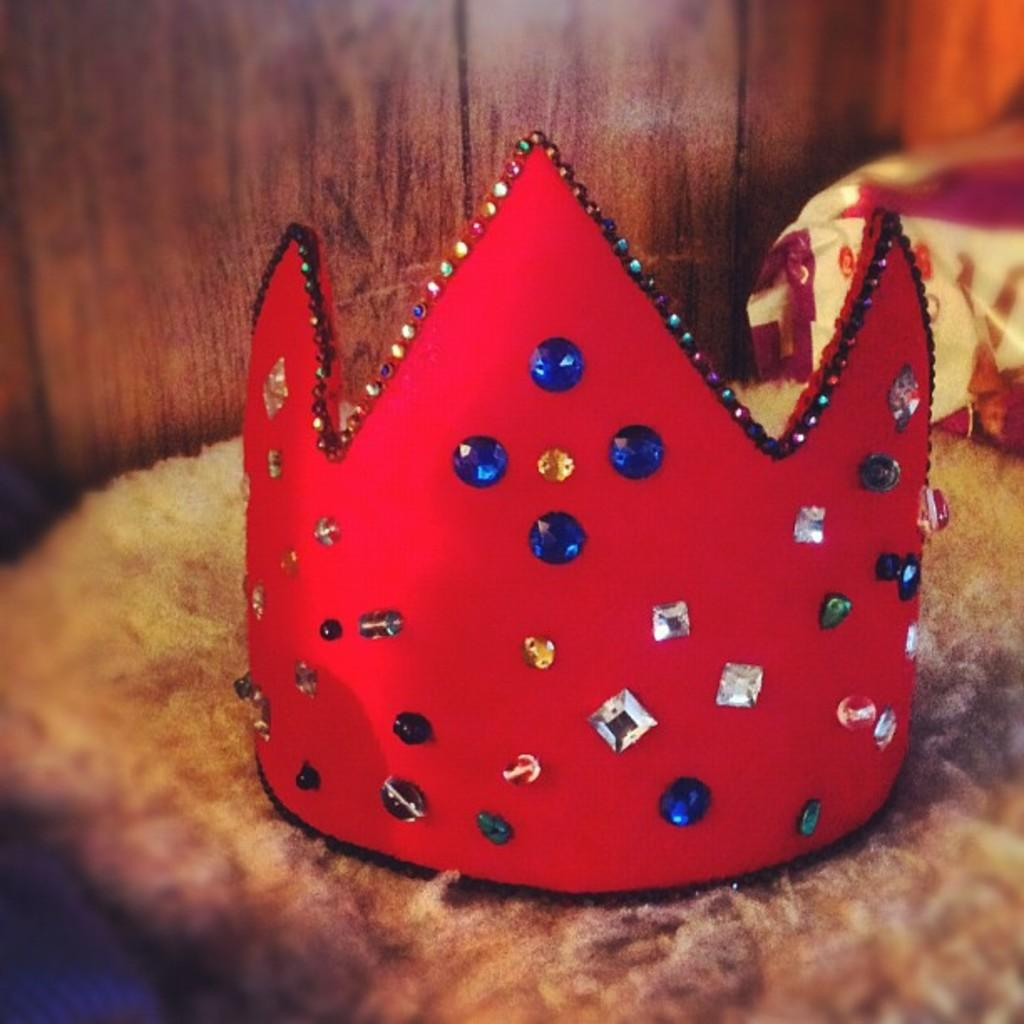What is the prominent object in the image? There is a crown in the image. What is the surface on which the crown might be placed? There is a mat in the image, which could serve as a surface for the crown. Is there any covering or protection visible in the image? Yes, there is a cover in the image. What type of wall can be seen in the image? There is a wooden wall in the image. What time of day is it in the image, and is there any quicksand present? The time of day is not mentioned in the image, and there is no quicksand present. Are there any screws visible in the image? There is no mention of screws in the provided facts, so we cannot determine if any are present in the image. 